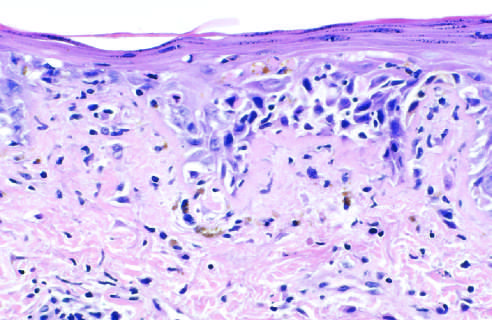does the remote kidney infarct show liquefactive degeneration of the basal layer of the epidermis and edema at the dermoepidermal junction?
Answer the question using a single word or phrase. No 